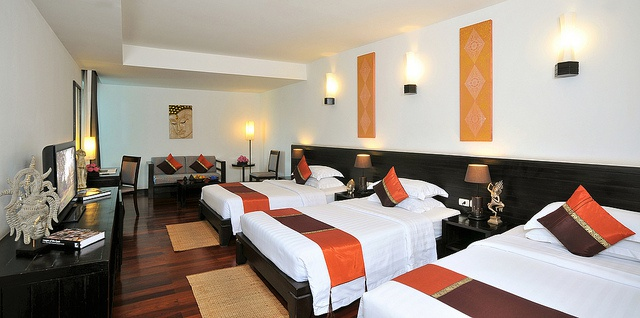Describe the objects in this image and their specific colors. I can see bed in darkgray, lightgray, maroon, red, and black tones, bed in darkgray, lightgray, black, red, and maroon tones, bed in darkgray, lightgray, and black tones, couch in darkgray, black, gray, and brown tones, and tv in darkgray, black, gray, and white tones in this image. 